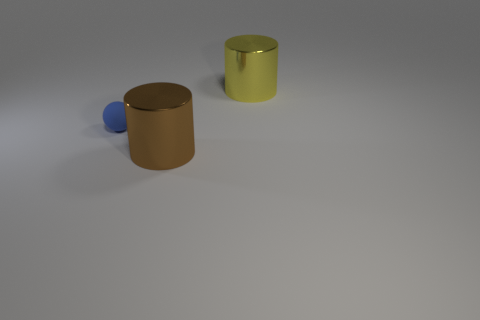Add 3 small yellow blocks. How many objects exist? 6 Subtract all balls. How many objects are left? 2 Subtract all green rubber things. Subtract all matte objects. How many objects are left? 2 Add 1 large yellow cylinders. How many large yellow cylinders are left? 2 Add 2 metal things. How many metal things exist? 4 Subtract 1 blue spheres. How many objects are left? 2 